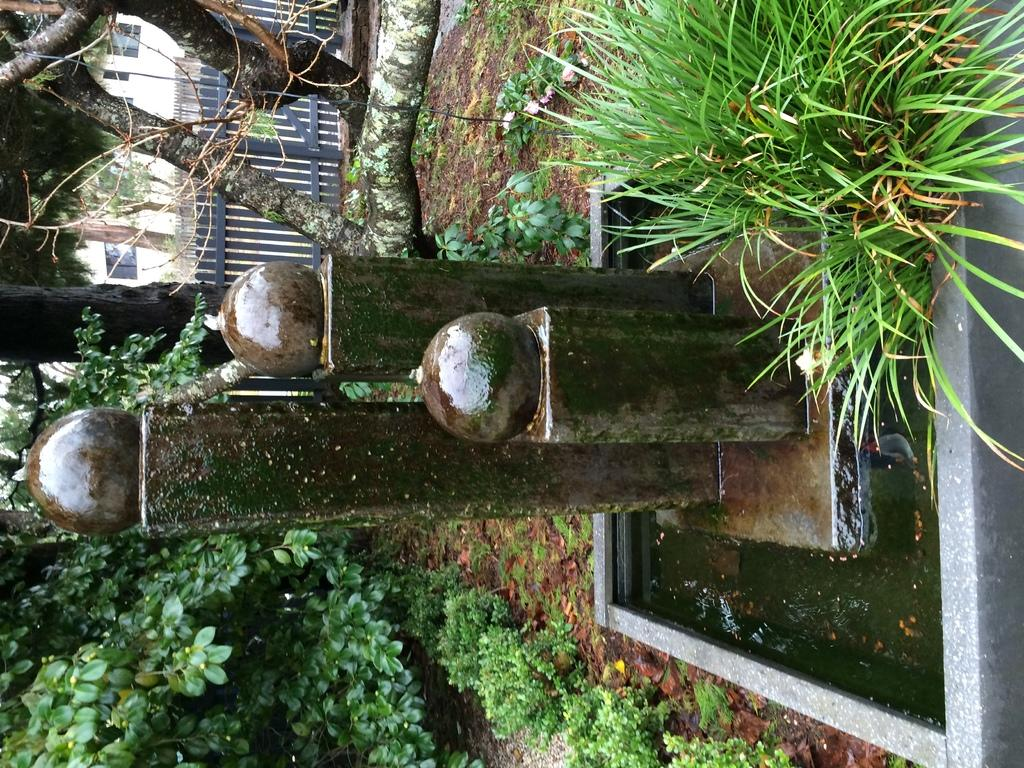What type of water feature is present in the image? The image contains a water feature, but the specific type is not mentioned. What type of vegetation can be seen in the image? There is grass, plants, and trees visible in the image. What is the purpose of the fence in the image? The purpose of the fence in the image is not mentioned, but it could be for enclosing or separating areas. What type of structure is visible in the image? There appears to be a building in the image. What type of pie is being served on the chessboard in the image? There is no pie or chessboard present in the image. What type of lace is used to decorate the trees in the image? There is no lace used to decorate the trees in the image; the trees are natural vegetation. 